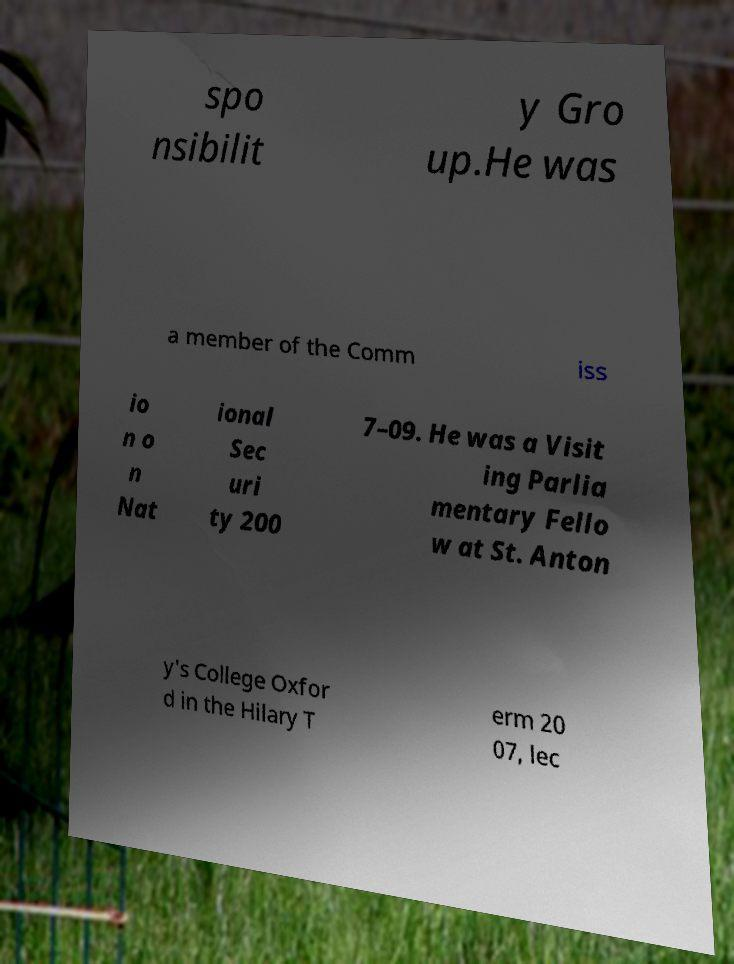Can you accurately transcribe the text from the provided image for me? spo nsibilit y Gro up.He was a member of the Comm iss io n o n Nat ional Sec uri ty 200 7–09. He was a Visit ing Parlia mentary Fello w at St. Anton y's College Oxfor d in the Hilary T erm 20 07, lec 